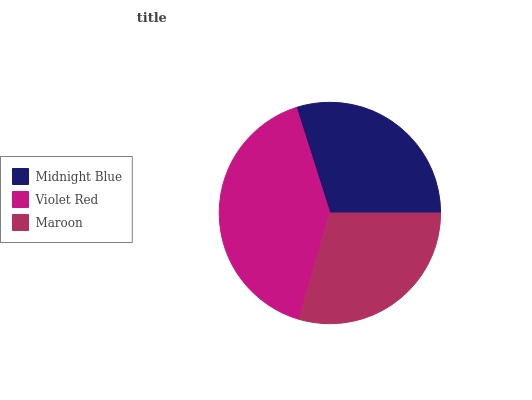Is Maroon the minimum?
Answer yes or no. Yes. Is Violet Red the maximum?
Answer yes or no. Yes. Is Violet Red the minimum?
Answer yes or no. No. Is Maroon the maximum?
Answer yes or no. No. Is Violet Red greater than Maroon?
Answer yes or no. Yes. Is Maroon less than Violet Red?
Answer yes or no. Yes. Is Maroon greater than Violet Red?
Answer yes or no. No. Is Violet Red less than Maroon?
Answer yes or no. No. Is Midnight Blue the high median?
Answer yes or no. Yes. Is Midnight Blue the low median?
Answer yes or no. Yes. Is Violet Red the high median?
Answer yes or no. No. Is Violet Red the low median?
Answer yes or no. No. 